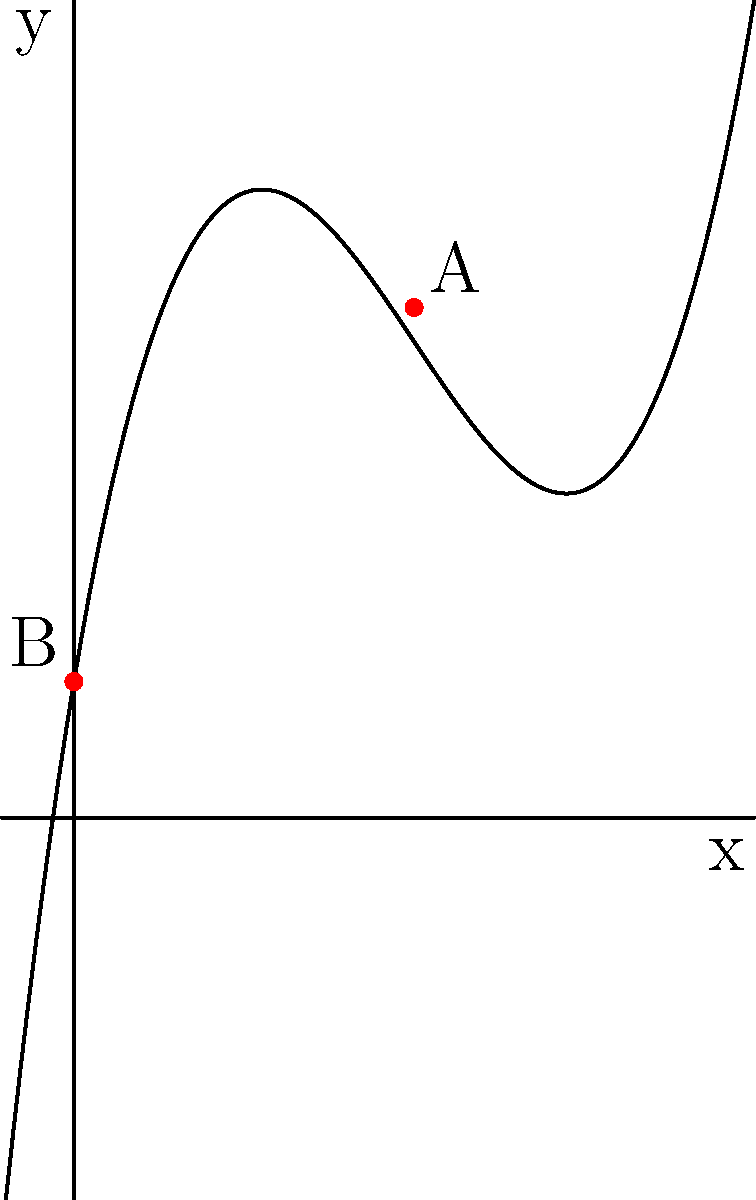As a prescriptivist grammarian, you believe that minimizing language errors is crucial for effective communication. The function $f(x) = 0.1x^3 - 1.5x^2 + 6x + 2$ represents the relationship between the number of errors (x) and the clarity of communication (y) in a written document. Find the number of errors that maximizes communication clarity, and explain why this supports the prescriptivist view on language usage. To find the maximum point of the function, we need to follow these steps:

1) First, find the derivative of the function:
   $$f'(x) = 0.3x^2 - 3x + 6$$

2) Set the derivative equal to zero to find critical points:
   $$0.3x^2 - 3x + 6 = 0$$

3) Solve this quadratic equation:
   $$x = \frac{3 \pm \sqrt{9 - 4(0.3)(6)}}{2(0.3)} = \frac{3 \pm \sqrt{-3.2}}{0.6}$$

4) Since the discriminant is negative, there are no real solutions. This means the function has no local maximum or minimum within its domain.

5) However, we can see from the graph that there's a global maximum at x = 0, which corresponds to point B (0, 2).

6) This result supports the prescriptivist view because it shows that communication clarity is maximized when there are zero errors (x = 0). As the number of errors increases, the clarity of communication decreases, which aligns with the prescriptivist belief in strict adherence to grammatical rules for effective communication.
Answer: 0 errors 